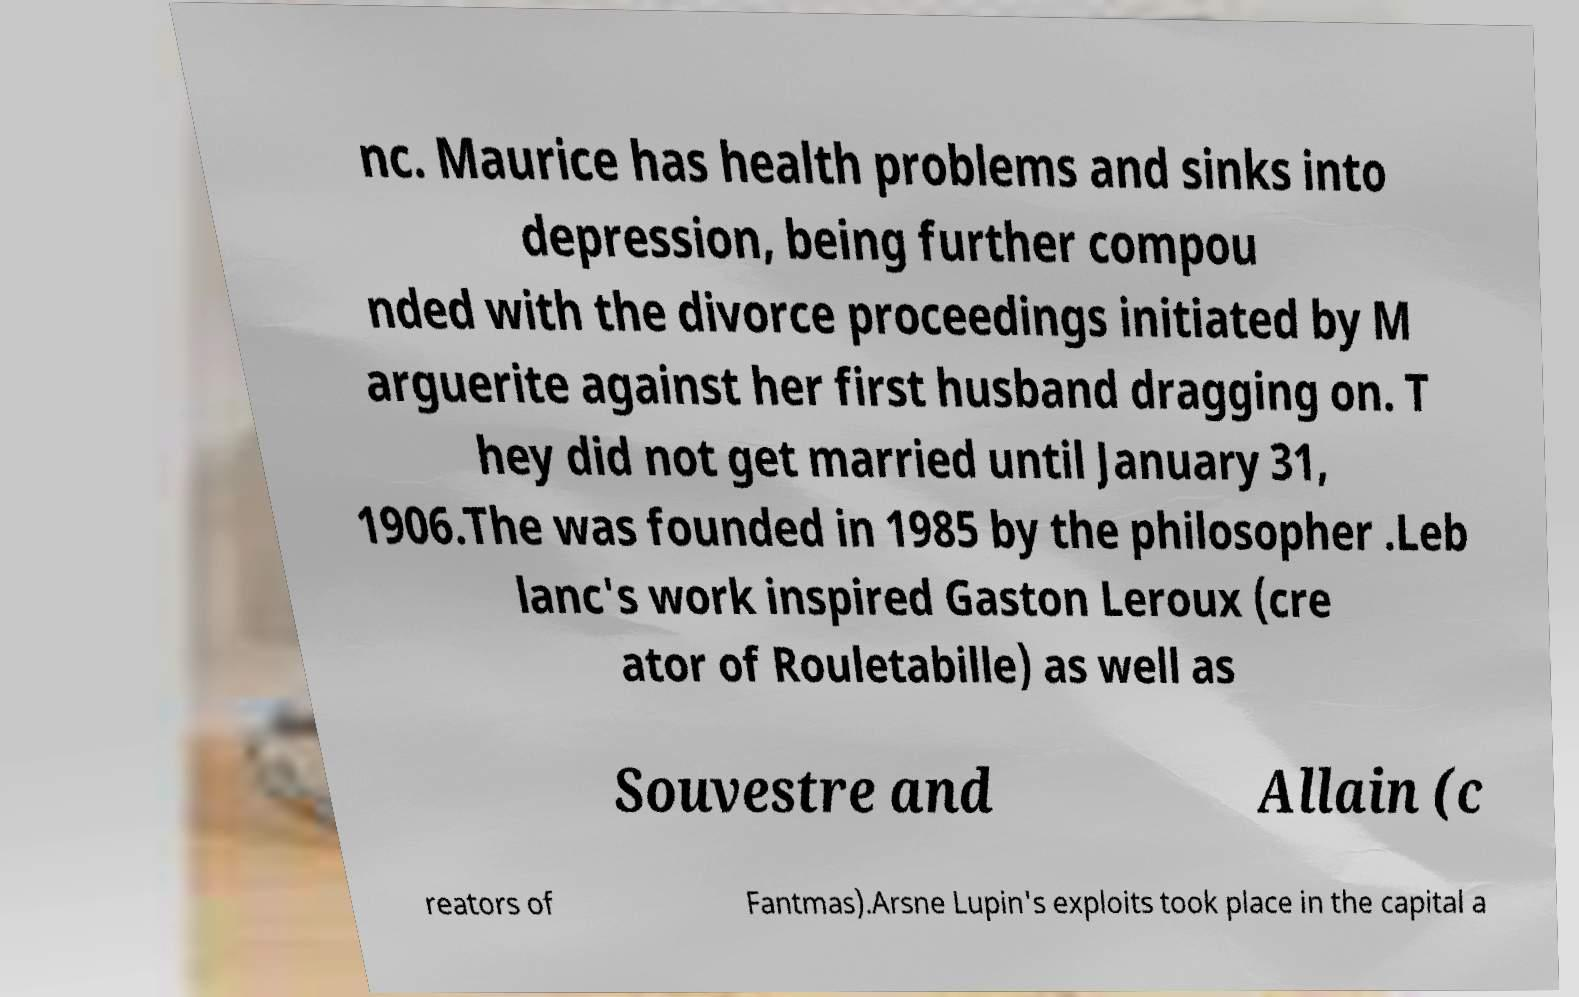Could you assist in decoding the text presented in this image and type it out clearly? nc. Maurice has health problems and sinks into depression, being further compou nded with the divorce proceedings initiated by M arguerite against her first husband dragging on. T hey did not get married until January 31, 1906.The was founded in 1985 by the philosopher .Leb lanc's work inspired Gaston Leroux (cre ator of Rouletabille) as well as Souvestre and Allain (c reators of Fantmas).Arsne Lupin's exploits took place in the capital a 